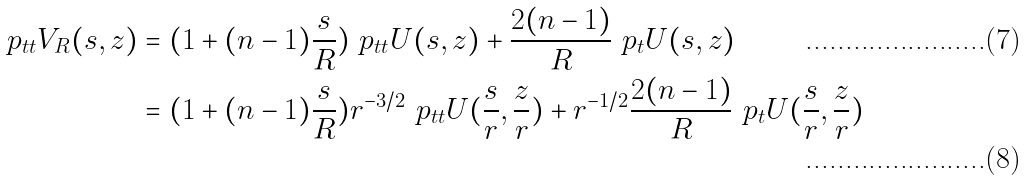<formula> <loc_0><loc_0><loc_500><loc_500>\ p _ { t t } V _ { R } ( s , z ) & = ( 1 + ( n - 1 ) \frac { s } { R } ) \ p _ { t t } U ( s , z ) + \frac { 2 ( n - 1 ) } { R } \ p _ { t } U ( s , z ) \\ & = ( 1 + ( n - 1 ) \frac { s } { R } ) r ^ { - 3 / 2 } \ p _ { t t } U ( \frac { s } { r } , \frac { z } { r } ) + r ^ { - 1 / 2 } \frac { 2 ( n - 1 ) } { R } \ p _ { t } U ( \frac { s } { r } , \frac { z } { r } )</formula> 